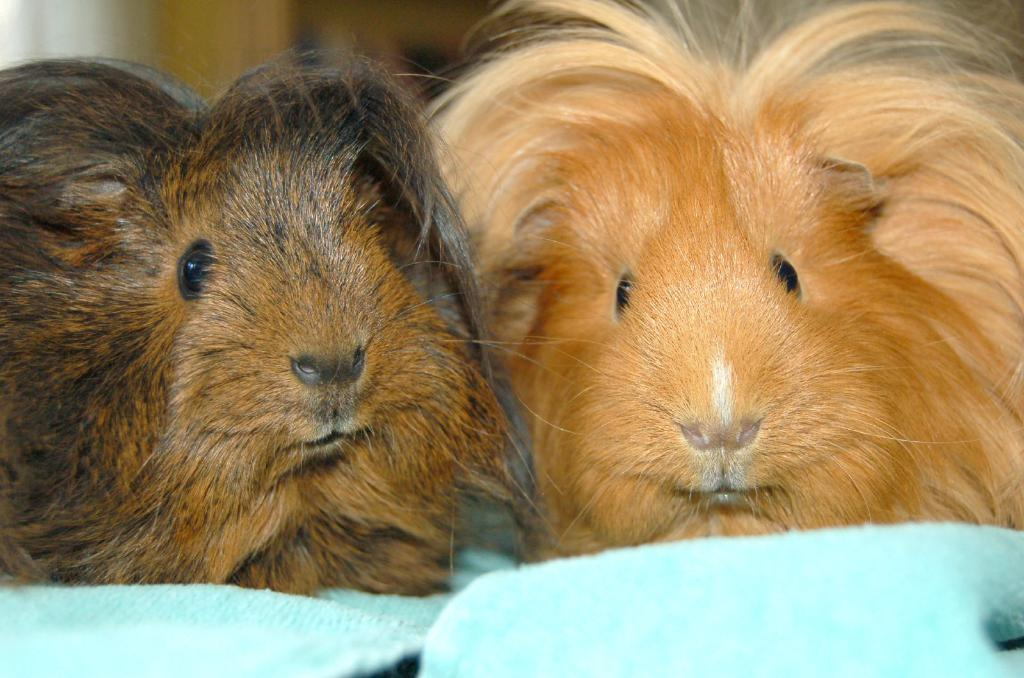What type of animal is present in the image? There is a guinea pig in the image. Can you describe the color of the first guinea pig? The first guinea pig has a cream color. Are there any other guinea pigs in the image? Yes, there is another guinea pig in the image. What is the color of the second guinea pig? The second guinea pig has a brown color. What type of drug is the guinea pig using in the image? There is no drug present in the image; it features two guinea pigs of different colors. 